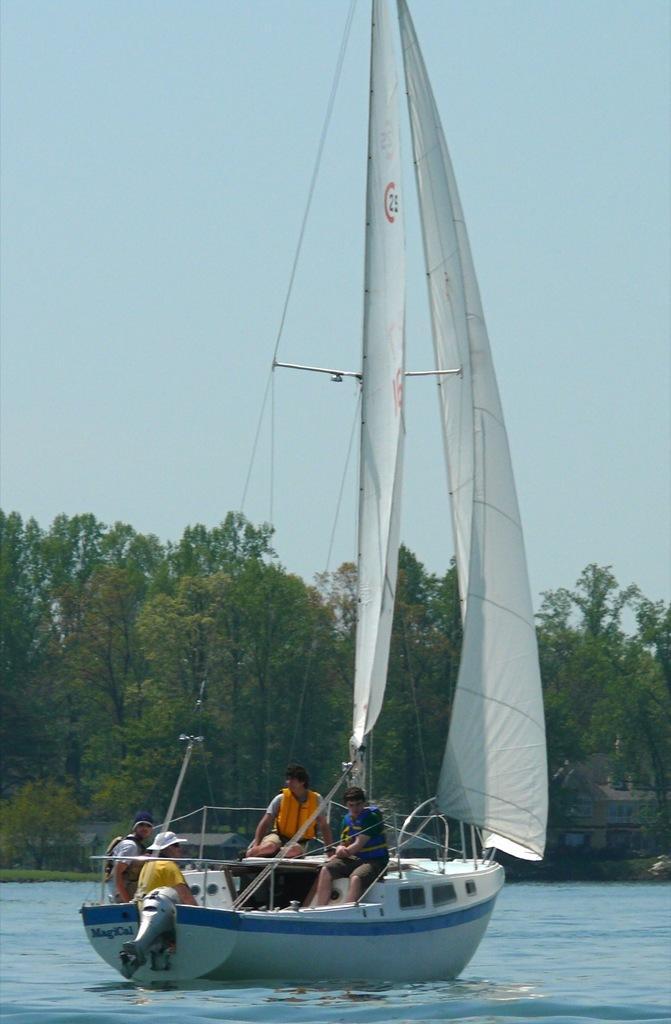Please provide a concise description of this image. This image is clicked outside. There is water at the bottom. On that there is a boat. In that there are some persons. There are trees in the middle. There is sky at the top. 